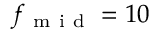<formula> <loc_0><loc_0><loc_500><loc_500>f _ { m i d } = 1 0</formula> 